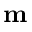Convert formula to latex. <formula><loc_0><loc_0><loc_500><loc_500>m</formula> 